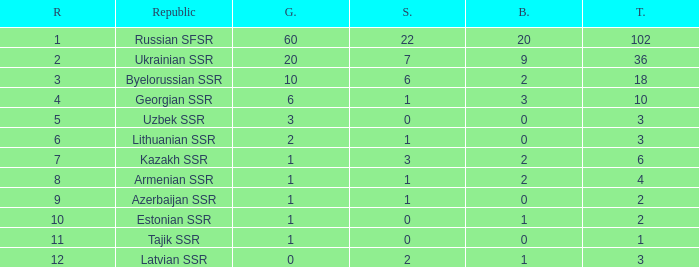What is the average total for teams with more than 1 gold, ranked over 3 and more than 3 bronze? None. 